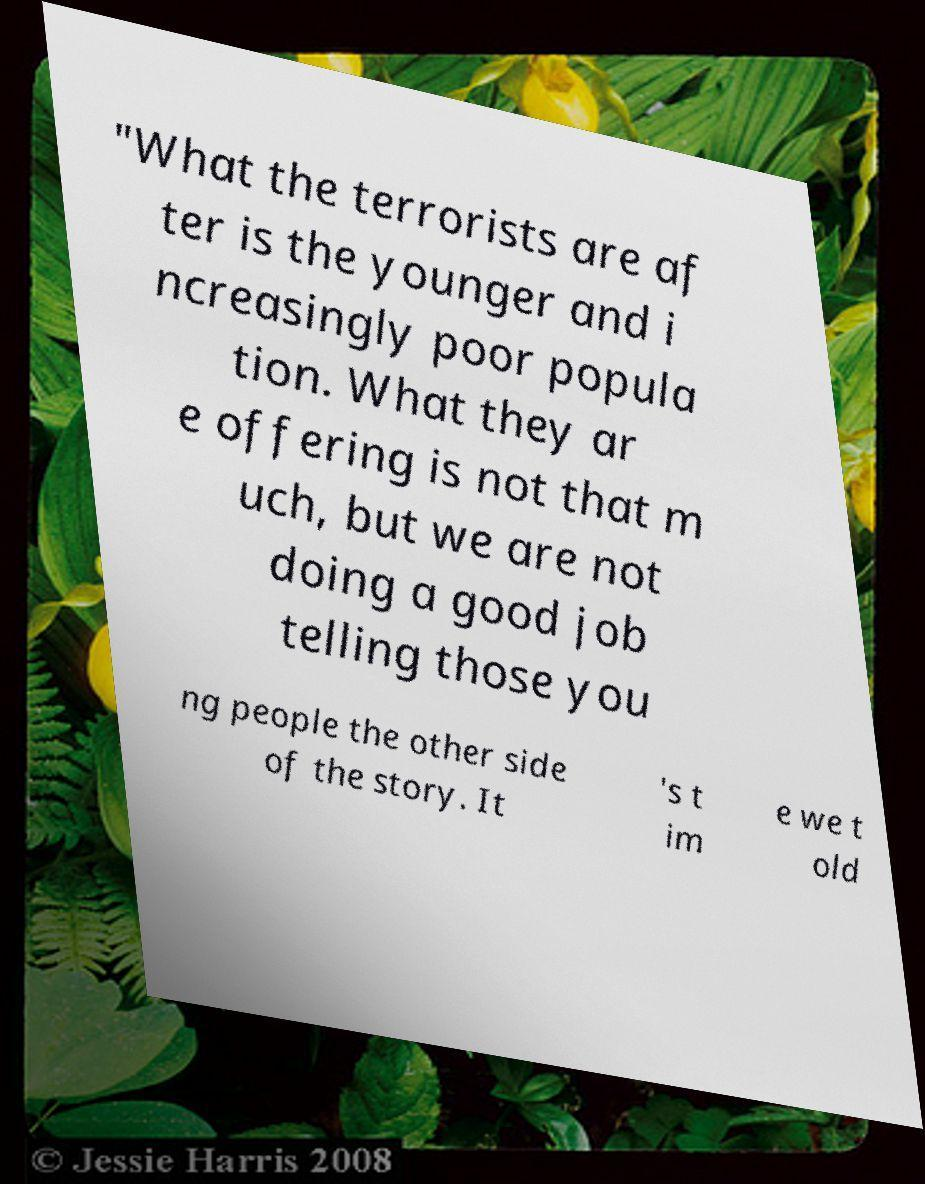Please identify and transcribe the text found in this image. "What the terrorists are af ter is the younger and i ncreasingly poor popula tion. What they ar e offering is not that m uch, but we are not doing a good job telling those you ng people the other side of the story. It 's t im e we t old 